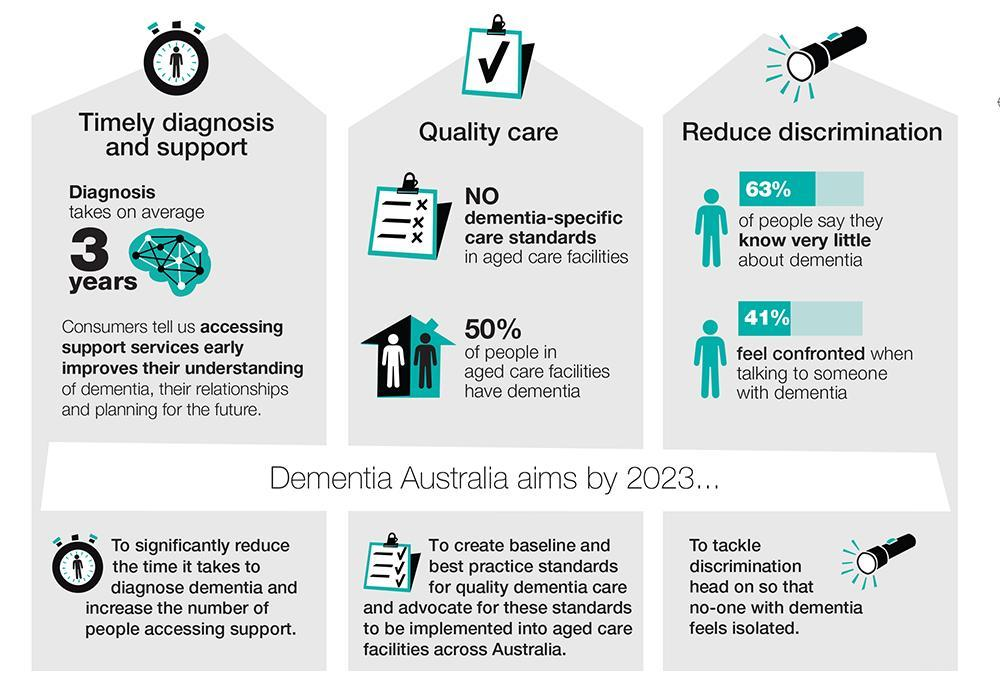What percentage of people do not feel confronted when talking to someone with dementia in Australia?
Answer the question with a short phrase. 59% What percentage of people in age cared facilities have dementia in Australia? 50% What percentage of people say they know very little about dementia in Australia? 63% 